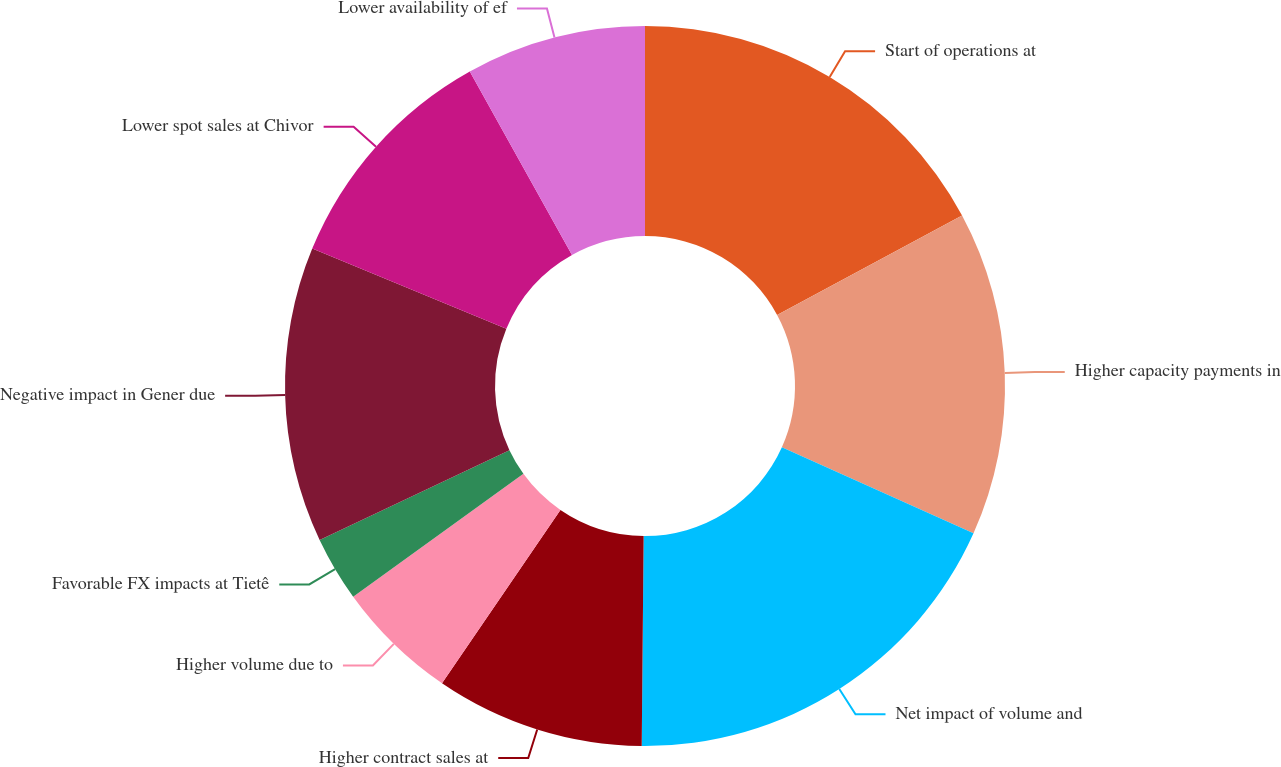<chart> <loc_0><loc_0><loc_500><loc_500><pie_chart><fcel>Start of operations at<fcel>Higher capacity payments in<fcel>Net impact of volume and<fcel>Higher contract sales at<fcel>Higher volume due to<fcel>Favorable FX impacts at Tietê<fcel>Negative impact in Gener due<fcel>Lower spot sales at Chivor<fcel>Lower availability of ef<nl><fcel>17.15%<fcel>14.56%<fcel>18.44%<fcel>9.39%<fcel>5.51%<fcel>2.92%<fcel>13.27%<fcel>10.68%<fcel>8.09%<nl></chart> 